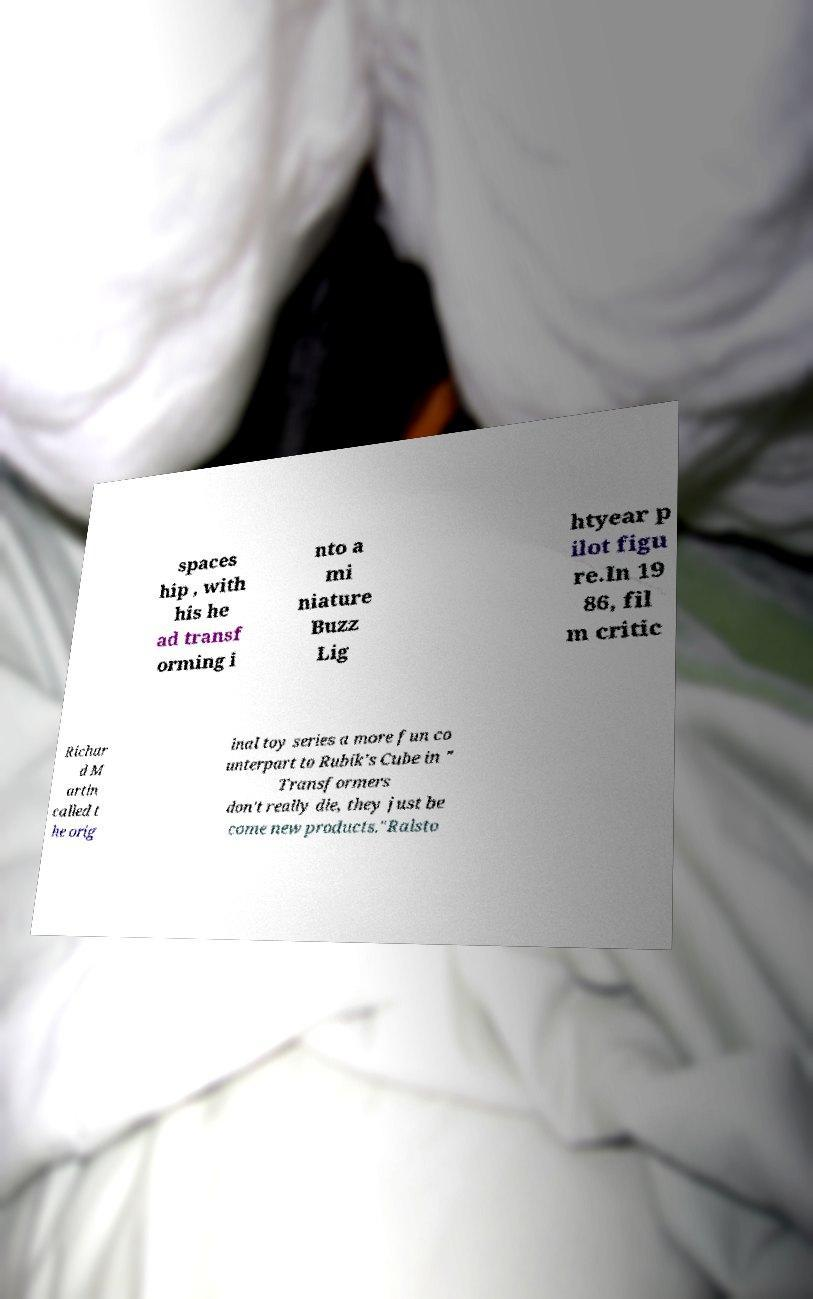Can you accurately transcribe the text from the provided image for me? spaces hip , with his he ad transf orming i nto a mi niature Buzz Lig htyear p ilot figu re.In 19 86, fil m critic Richar d M artin called t he orig inal toy series a more fun co unterpart to Rubik's Cube in " Transformers don't really die, they just be come new products."Ralsto 